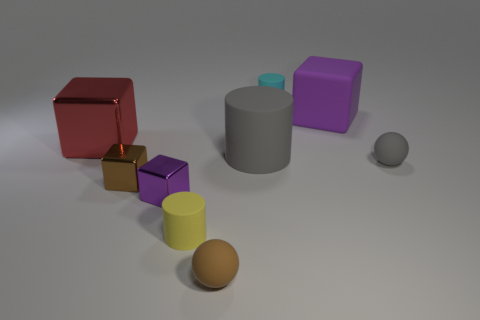Subtract all spheres. How many objects are left? 7 Add 2 cyan cylinders. How many cyan cylinders exist? 3 Subtract 1 red cubes. How many objects are left? 8 Subtract all blue rubber spheres. Subtract all cyan rubber things. How many objects are left? 8 Add 2 large purple matte blocks. How many large purple matte blocks are left? 3 